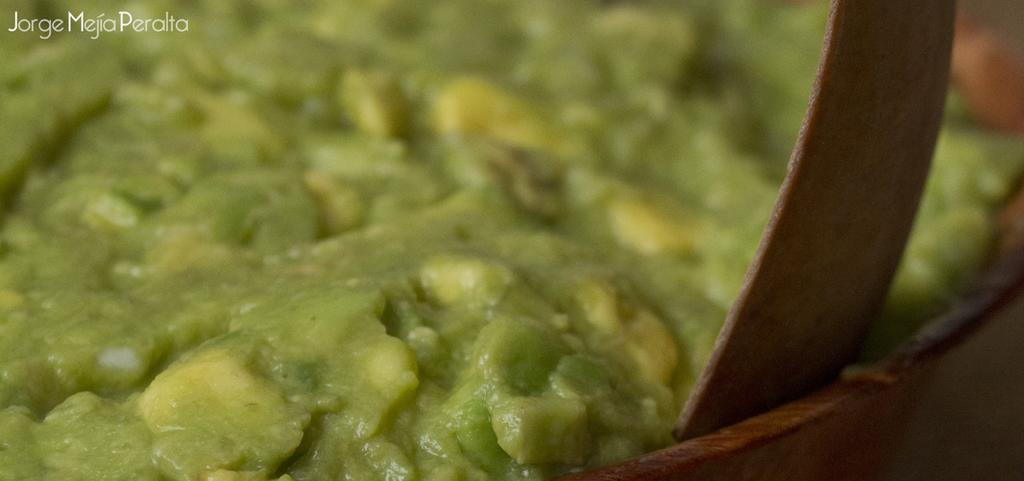What is inside the container in the image? There is a food item in the container. Can you tell me how many fish are swimming in the container? There are no fish present in the image; it contains a food item. What type of credit can be seen on the container? There is no credit or label visible on the container in the image. 